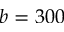<formula> <loc_0><loc_0><loc_500><loc_500>b = 3 0 0</formula> 